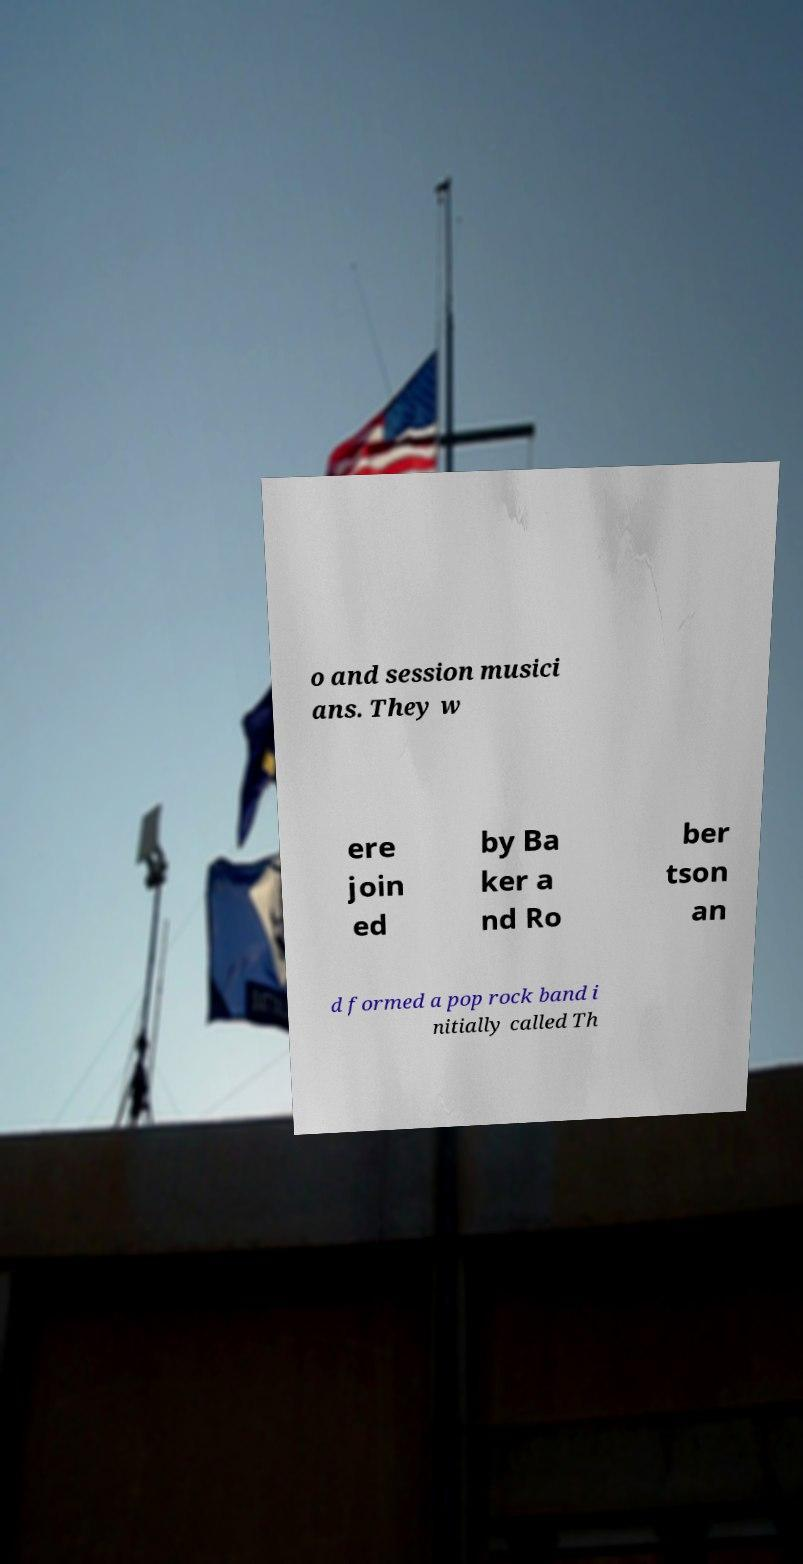Please identify and transcribe the text found in this image. o and session musici ans. They w ere join ed by Ba ker a nd Ro ber tson an d formed a pop rock band i nitially called Th 